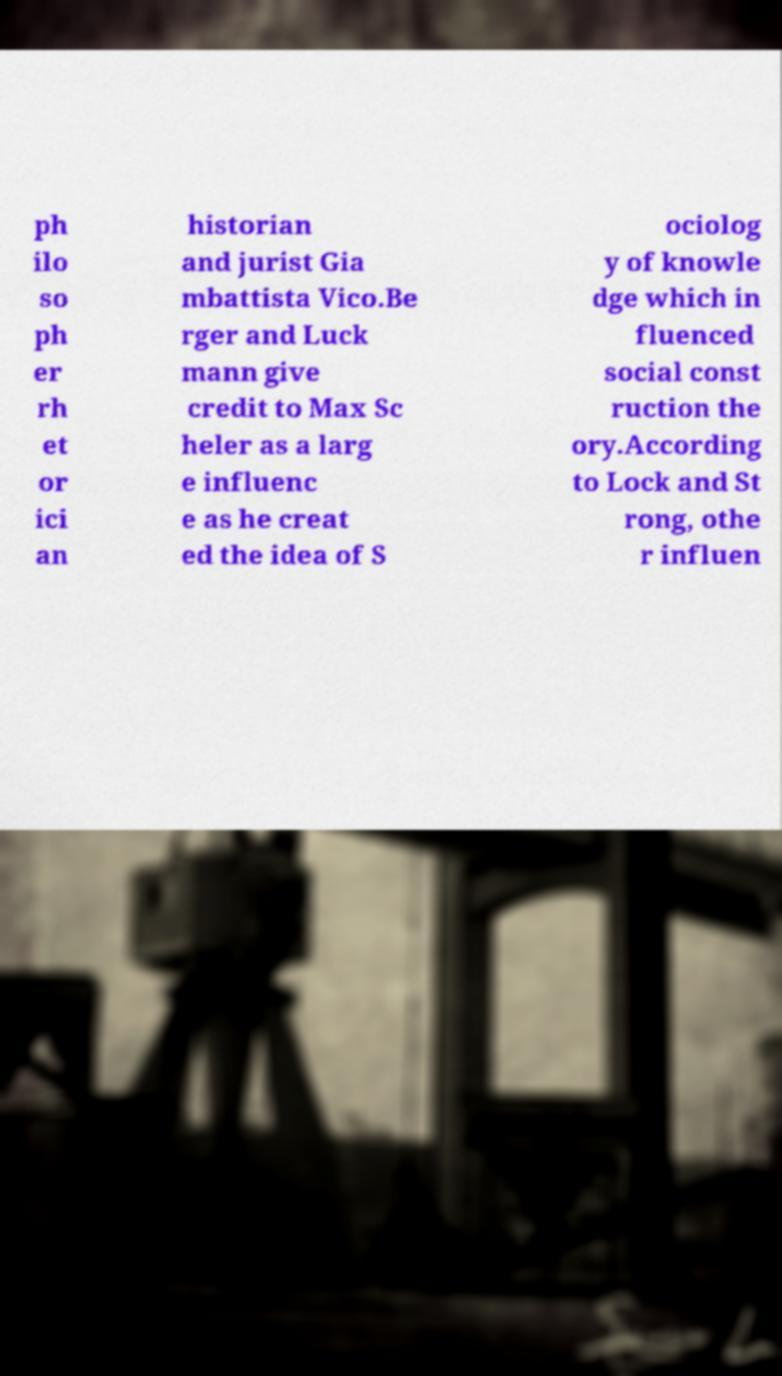Could you assist in decoding the text presented in this image and type it out clearly? ph ilo so ph er rh et or ici an historian and jurist Gia mbattista Vico.Be rger and Luck mann give credit to Max Sc heler as a larg e influenc e as he creat ed the idea of S ociolog y of knowle dge which in fluenced social const ruction the ory.According to Lock and St rong, othe r influen 